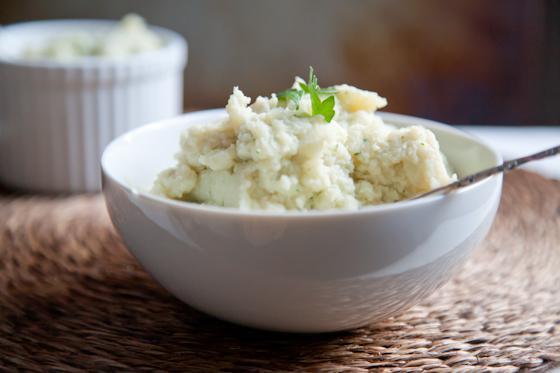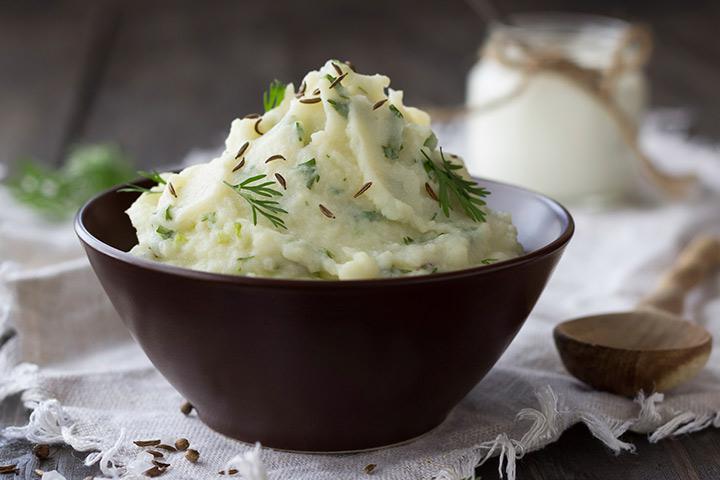The first image is the image on the left, the second image is the image on the right. Considering the images on both sides, is "A white bowl of mashed potato is on top of a round placemat." valid? Answer yes or no. Yes. 